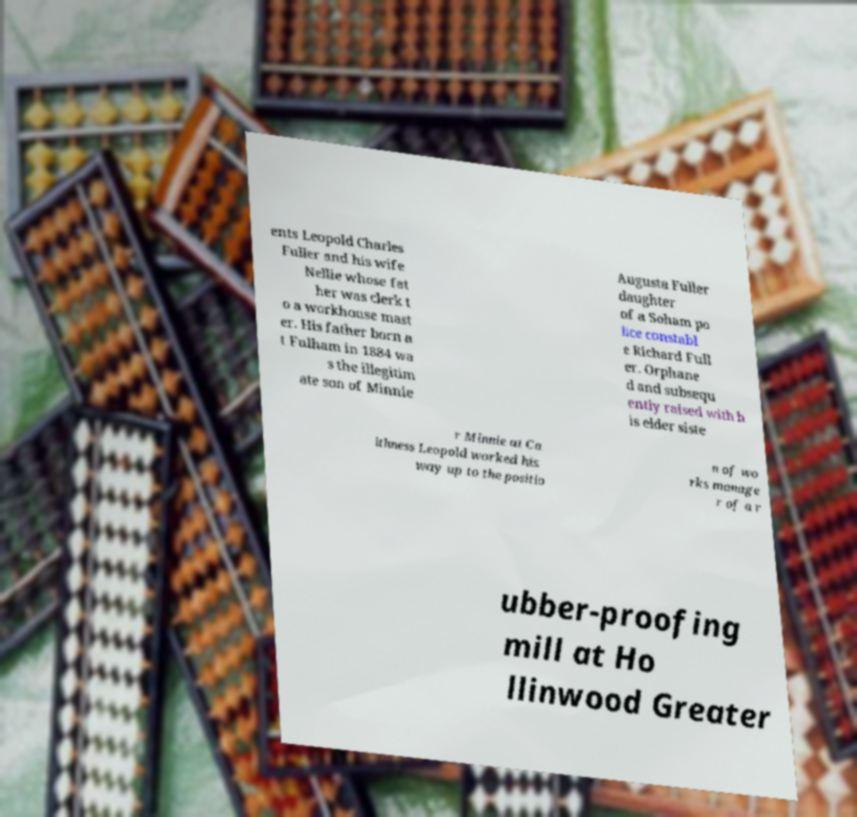Could you assist in decoding the text presented in this image and type it out clearly? ents Leopold Charles Fuller and his wife Nellie whose fat her was clerk t o a workhouse mast er. His father born a t Fulham in 1884 wa s the illegitim ate son of Minnie Augusta Fuller daughter of a Soham po lice constabl e Richard Full er. Orphane d and subsequ ently raised with h is elder siste r Minnie at Ca ithness Leopold worked his way up to the positio n of wo rks manage r of a r ubber-proofing mill at Ho llinwood Greater 